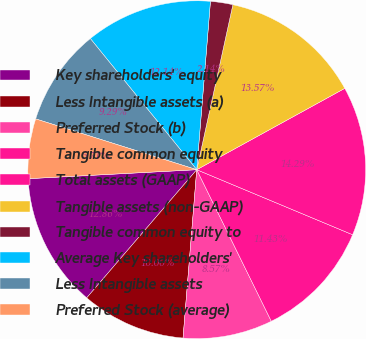<chart> <loc_0><loc_0><loc_500><loc_500><pie_chart><fcel>Key shareholders' equity<fcel>Less Intangible assets (a)<fcel>Preferred Stock (b)<fcel>Tangible common equity<fcel>Total assets (GAAP)<fcel>Tangible assets (non-GAAP)<fcel>Tangible common equity to<fcel>Average Key shareholders'<fcel>Less Intangible assets<fcel>Preferred Stock (average)<nl><fcel>12.86%<fcel>10.0%<fcel>8.57%<fcel>11.43%<fcel>14.29%<fcel>13.57%<fcel>2.14%<fcel>12.14%<fcel>9.29%<fcel>5.71%<nl></chart> 